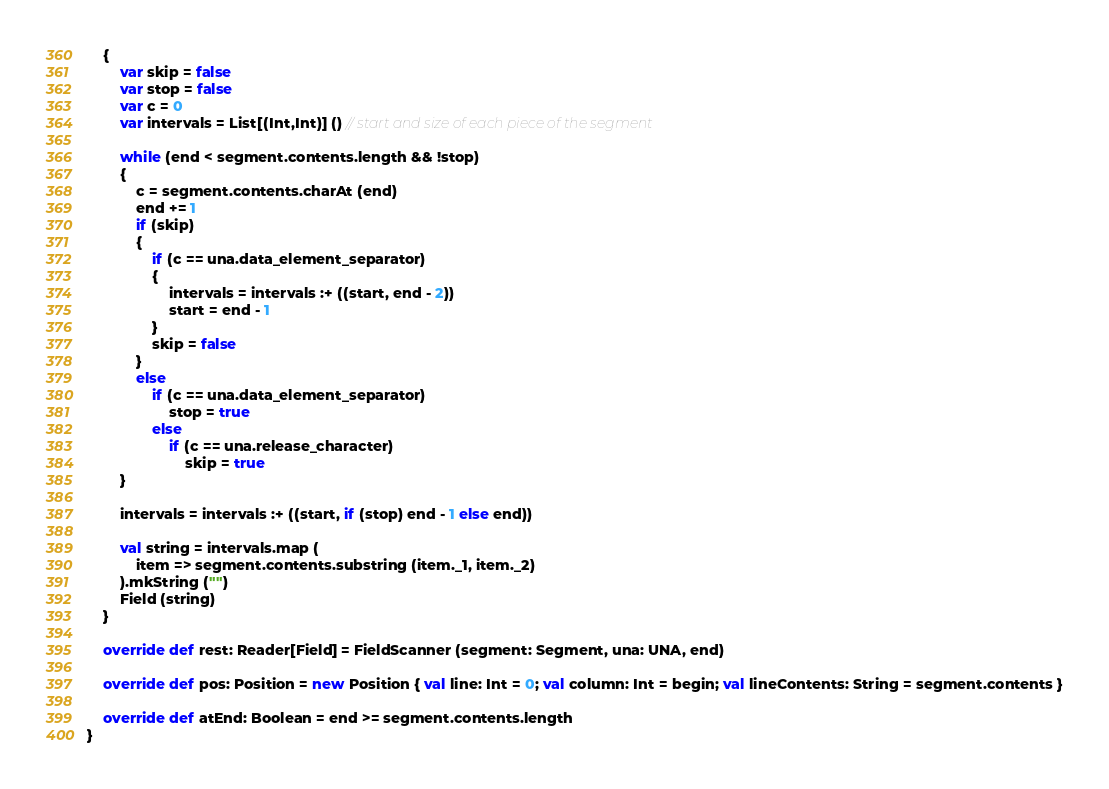Convert code to text. <code><loc_0><loc_0><loc_500><loc_500><_Scala_>    {
        var skip = false
        var stop = false
        var c = 0
        var intervals = List[(Int,Int)] () // start and size of each piece of the segment

        while (end < segment.contents.length && !stop)
        {
            c = segment.contents.charAt (end)
            end += 1
            if (skip)
            {
                if (c == una.data_element_separator)
                {
                    intervals = intervals :+ ((start, end - 2))
                    start = end - 1
                }
                skip = false
            }
            else
                if (c == una.data_element_separator)
                    stop = true
                else
                    if (c == una.release_character)
                        skip = true
        }

        intervals = intervals :+ ((start, if (stop) end - 1 else end))

        val string = intervals.map (
            item => segment.contents.substring (item._1, item._2)
        ).mkString ("")
        Field (string)
    }

    override def rest: Reader[Field] = FieldScanner (segment: Segment, una: UNA, end)

    override def pos: Position = new Position { val line: Int = 0; val column: Int = begin; val lineContents: String = segment.contents }

    override def atEnd: Boolean = end >= segment.contents.length
}
</code> 